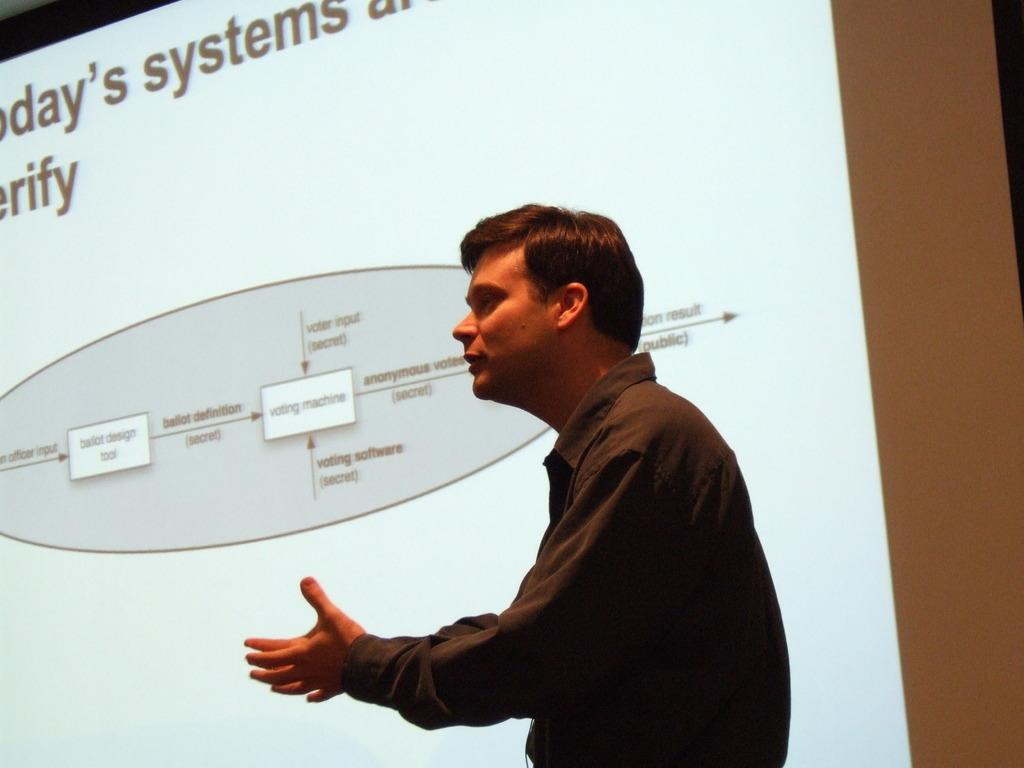What is the main object in the image? There is a projector screen in the image. Is there anyone present in the image? Yes, there is a person standing in the image. What type of window is visible in the image? There is no window present in the image; it only features a projector screen and a person. What is the person eating for breakfast in the image? There is no breakfast or eating activity depicted in the image. 